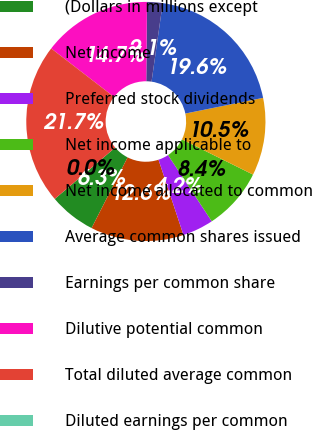Convert chart. <chart><loc_0><loc_0><loc_500><loc_500><pie_chart><fcel>(Dollars in millions except<fcel>Net income<fcel>Preferred stock dividends<fcel>Net income applicable to<fcel>Net income allocated to common<fcel>Average common shares issued<fcel>Earnings per common share<fcel>Dilutive potential common<fcel>Total diluted average common<fcel>Diluted earnings per common<nl><fcel>6.29%<fcel>12.59%<fcel>4.2%<fcel>8.39%<fcel>10.49%<fcel>19.58%<fcel>2.1%<fcel>14.69%<fcel>21.67%<fcel>0.0%<nl></chart> 